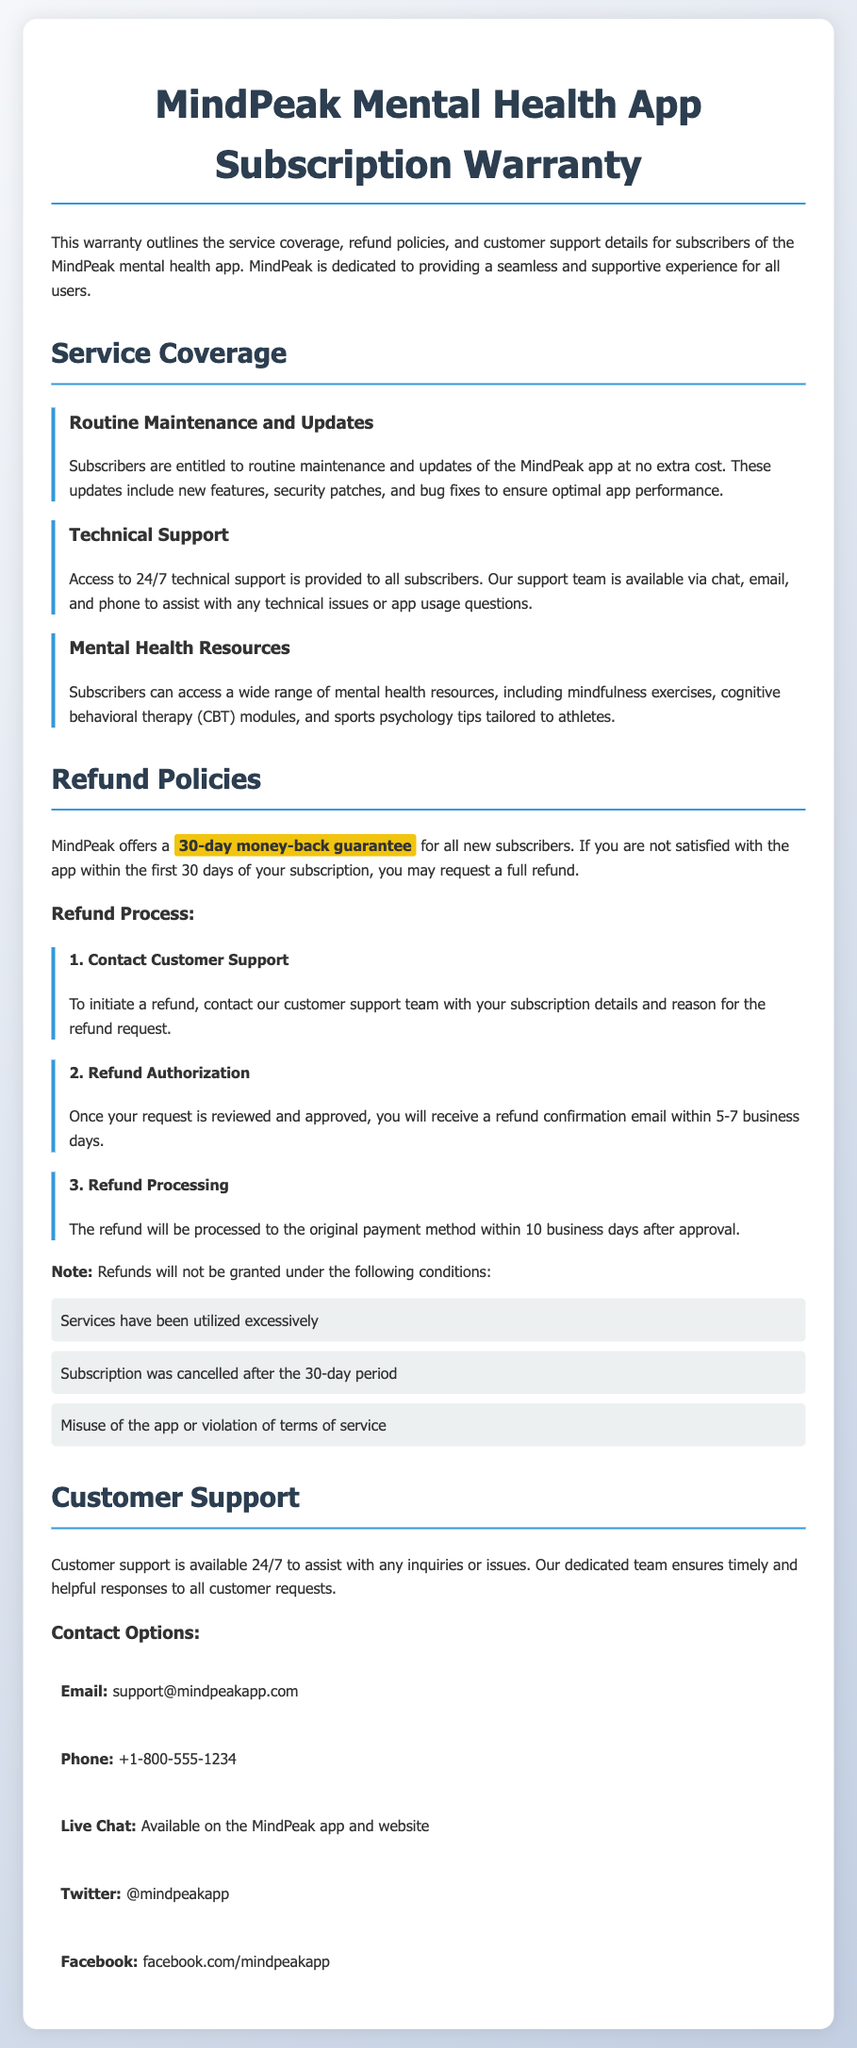What is the duration of the money-back guarantee? The document states that MindPeak offers a 30-day money-back guarantee for all new subscribers.
Answer: 30-day What type of resources can subscribers access? The document mentions that subscribers can access a wide range of mental health resources, including mindfulness exercises, cognitive behavioral therapy modules, and sports psychology tips.
Answer: Mental health resources Which contact method is available for live support? The document specifies that live chat is available on the MindPeak app and website for customer support.
Answer: Live Chat What is required to initiate the refund process? According to the document, to initiate a refund, users need to contact customer support with their subscription details and reason for the refund request.
Answer: Contact Customer Support How long does it take to receive a refund confirmation email after request approval? The document notes that once a refund request is reviewed and approved, users will receive a refund confirmation email within 5-7 business days.
Answer: 5-7 business days What happens if the subscription is canceled after the 30-day period? The document lists that refunds will not be granted if the subscription was canceled after the 30-day period.
Answer: Canceled after 30-day period How can customers contact support via email? The document provides the email address for support, which is support@mindpeakapp.com.
Answer: support@mindpeakapp.com What is the phone number for customer support? The document includes the phone number for customer support, which is +1-800-555-1234.
Answer: +1-800-555-1234 What can subscribers expect from routine maintenance? The document indicates that subscribers are entitled to routine maintenance and updates of the MindPeak app at no extra cost.
Answer: No extra cost 